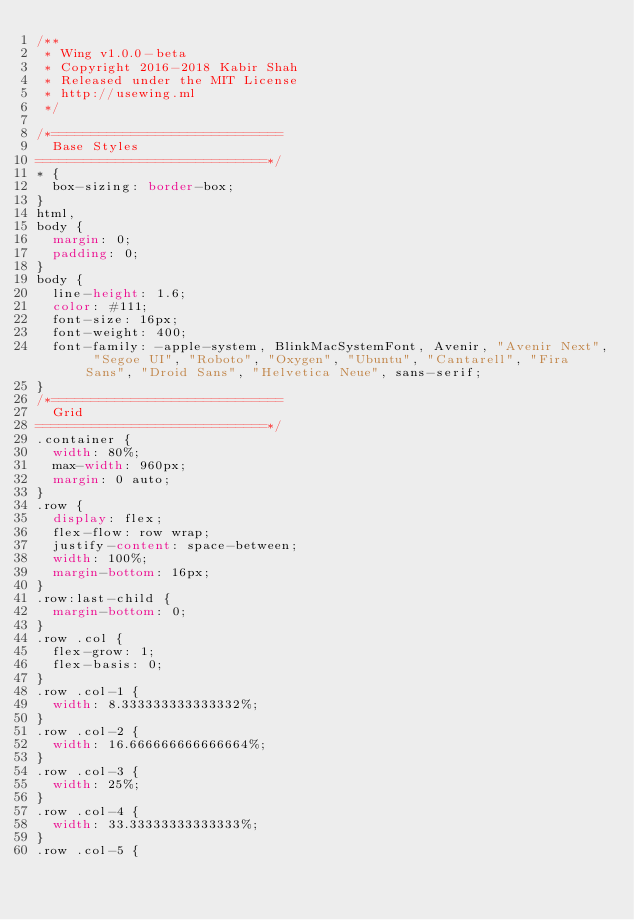Convert code to text. <code><loc_0><loc_0><loc_500><loc_500><_CSS_>/**
 * Wing v1.0.0-beta
 * Copyright 2016-2018 Kabir Shah
 * Released under the MIT License
 * http://usewing.ml
 */

/*=============================
  Base Styles
=============================*/
* {
  box-sizing: border-box;
}
html,
body {
  margin: 0;
  padding: 0;
}
body {
  line-height: 1.6;
  color: #111;
  font-size: 16px;
  font-weight: 400;
  font-family: -apple-system, BlinkMacSystemFont, Avenir, "Avenir Next", "Segoe UI", "Roboto", "Oxygen", "Ubuntu", "Cantarell", "Fira Sans", "Droid Sans", "Helvetica Neue", sans-serif;
}
/*=============================
  Grid
=============================*/
.container {
  width: 80%;
  max-width: 960px;
  margin: 0 auto;
}
.row {
  display: flex;
  flex-flow: row wrap;
  justify-content: space-between;
  width: 100%;
  margin-bottom: 16px;
}
.row:last-child {
  margin-bottom: 0;
}
.row .col {
  flex-grow: 1;
  flex-basis: 0;
}
.row .col-1 {
  width: 8.333333333333332%;
}
.row .col-2 {
  width: 16.666666666666664%;
}
.row .col-3 {
  width: 25%;
}
.row .col-4 {
  width: 33.33333333333333%;
}
.row .col-5 {</code> 